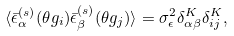Convert formula to latex. <formula><loc_0><loc_0><loc_500><loc_500>\langle { \bar { \epsilon } ^ { ( s ) } } _ { \alpha } ( \theta g _ { i } ) { \bar { \epsilon } ^ { ( s ) } } _ { \beta } ( \theta g _ { j } ) \rangle = \sigma ^ { 2 } _ { \epsilon } \delta ^ { K } _ { \alpha \beta } \delta ^ { K } _ { i j } ,</formula> 